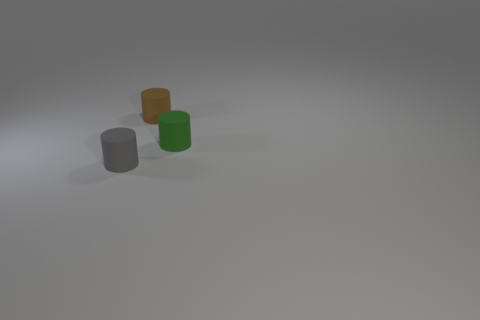Subtract 1 cylinders. How many cylinders are left? 2 Add 1 small blue rubber cubes. How many objects exist? 4 Subtract 0 purple cylinders. How many objects are left? 3 Subtract all big brown cylinders. Subtract all rubber cylinders. How many objects are left? 0 Add 3 rubber things. How many rubber things are left? 6 Add 2 large brown things. How many large brown things exist? 2 